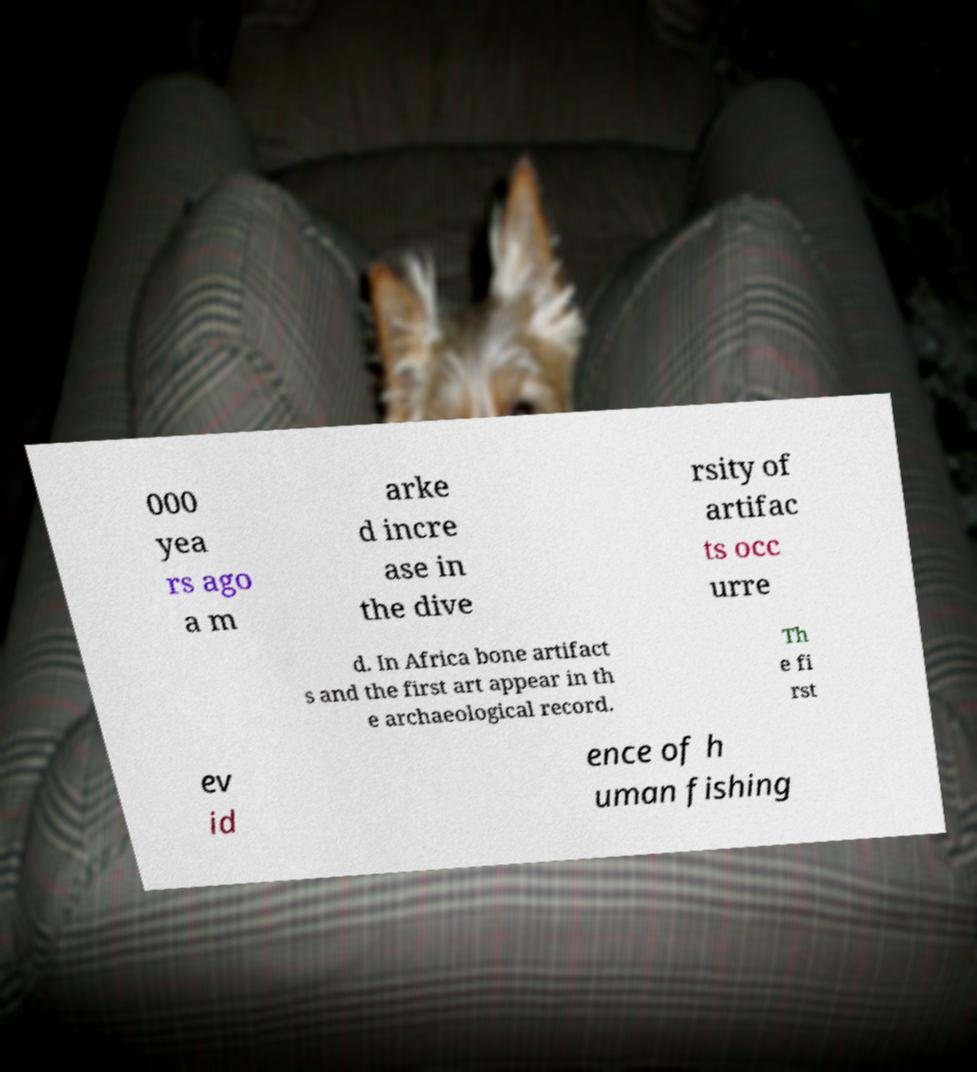Could you extract and type out the text from this image? 000 yea rs ago a m arke d incre ase in the dive rsity of artifac ts occ urre d. In Africa bone artifact s and the first art appear in th e archaeological record. Th e fi rst ev id ence of h uman fishing 